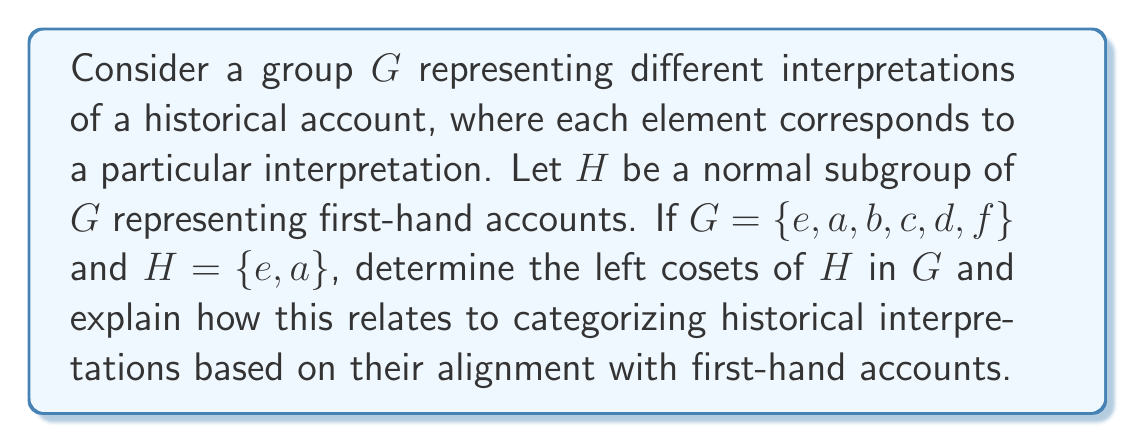Can you answer this question? To solve this problem, we'll follow these steps:

1) Recall that for a subgroup $H$ of a group $G$, the left cosets of $H$ in $G$ are sets of the form $gH = \{gh : h \in H\}$ for each $g \in G$.

2) Since $H = \{e, a\}$, we need to find $gH$ for each $g \in G$:

   $eH = \{eh : h \in H\} = \{e, a\}$
   $aH = \{ah : h \in H\} = \{a, e\}$ (since $a^2 = e$ in this group)
   $bH = \{bh : h \in H\} = \{b, ba\}$
   $cH = \{ch : h \in H\} = \{c, ca\}$
   $dH = \{dh : h \in H\} = \{d, da\}$
   $fH = \{fh : h \in H\} = \{f, fa\}$

3) We can see that $eH = aH = H$, and the other cosets are distinct.

4) Therefore, the distinct left cosets are:
   $H = \{e, a\}$
   $bH = \{b, ba\}$
   $cH = \{c, ca\}$
   $dH = \{d, da\}$
   $fH = \{f, fa\}$

5) In the context of historical interpretations:
   - The subgroup $H$ represents first-hand accounts and interpretations directly based on them.
   - Each coset represents a category of interpretations that are equivalent up to first-hand account information.
   - The number of distinct cosets (5 in this case) represents the number of fundamentally different categories of interpretations when considering first-hand accounts as the baseline.

This structure allows an editor to categorize different historical interpretations based on their alignment with first-hand accounts, which aligns with the persona's belief in the importance of such accounts in historical narratives.
Answer: The left cosets of $H$ in $G$ are:
$$H = \{e, a\}$$
$$bH = \{b, ba\}$$
$$cH = \{c, ca\}$$
$$dH = \{d, da\}$$
$$fH = \{f, fa\}$$
These cosets represent categories of historical interpretations based on their relationship to first-hand accounts. 